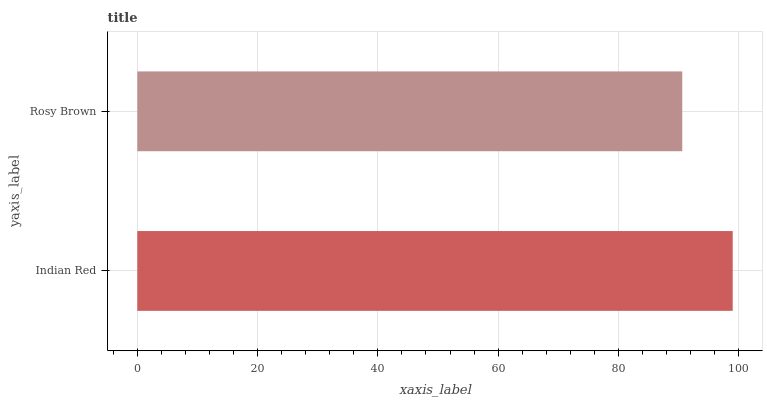Is Rosy Brown the minimum?
Answer yes or no. Yes. Is Indian Red the maximum?
Answer yes or no. Yes. Is Rosy Brown the maximum?
Answer yes or no. No. Is Indian Red greater than Rosy Brown?
Answer yes or no. Yes. Is Rosy Brown less than Indian Red?
Answer yes or no. Yes. Is Rosy Brown greater than Indian Red?
Answer yes or no. No. Is Indian Red less than Rosy Brown?
Answer yes or no. No. Is Indian Red the high median?
Answer yes or no. Yes. Is Rosy Brown the low median?
Answer yes or no. Yes. Is Rosy Brown the high median?
Answer yes or no. No. Is Indian Red the low median?
Answer yes or no. No. 